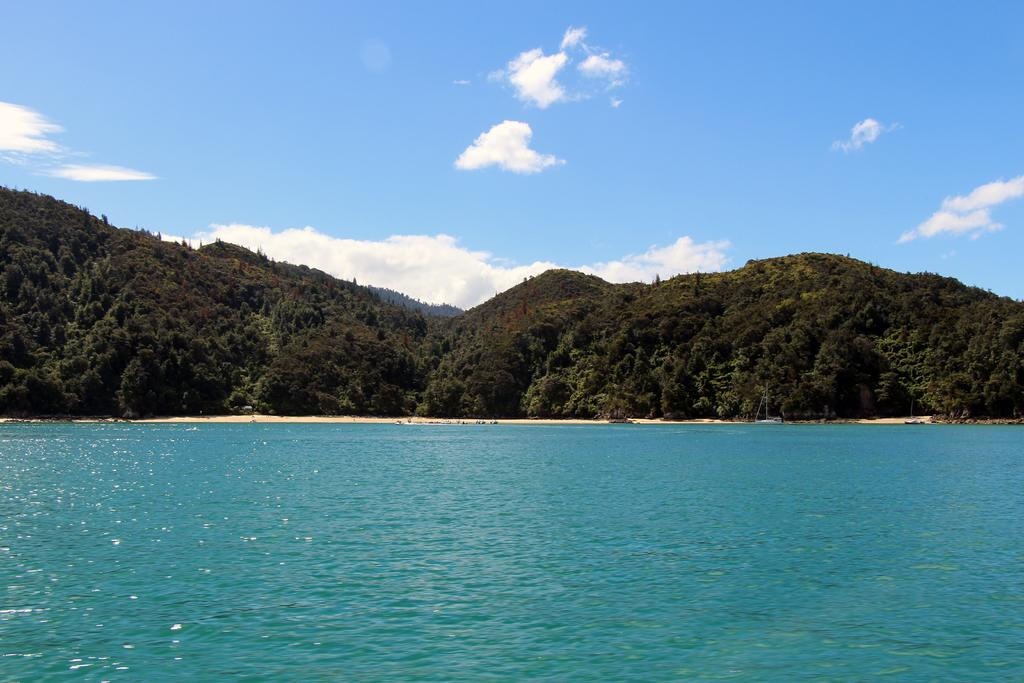What type of natural environment is depicted in the image? The image features an ocean, a beach, and a forest. What color is the sky in the image? The sky is blue in the image. Are there any additional weather features visible in the sky? Yes, there are clouds in the sky. What type of stone is being used to slow down the car in the image? There is no car or stone present in the image; it features an ocean, a beach, and a forest. 